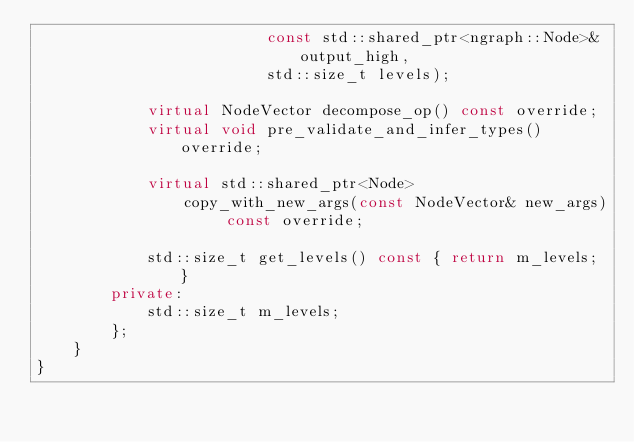Convert code to text. <code><loc_0><loc_0><loc_500><loc_500><_C++_>                         const std::shared_ptr<ngraph::Node>& output_high,
                         std::size_t levels);

            virtual NodeVector decompose_op() const override;
            virtual void pre_validate_and_infer_types() override;

            virtual std::shared_ptr<Node>
                copy_with_new_args(const NodeVector& new_args) const override;

            std::size_t get_levels() const { return m_levels; }
        private:
            std::size_t m_levels;
        };
    }
}
</code> 